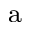<formula> <loc_0><loc_0><loc_500><loc_500>^ { a }</formula> 